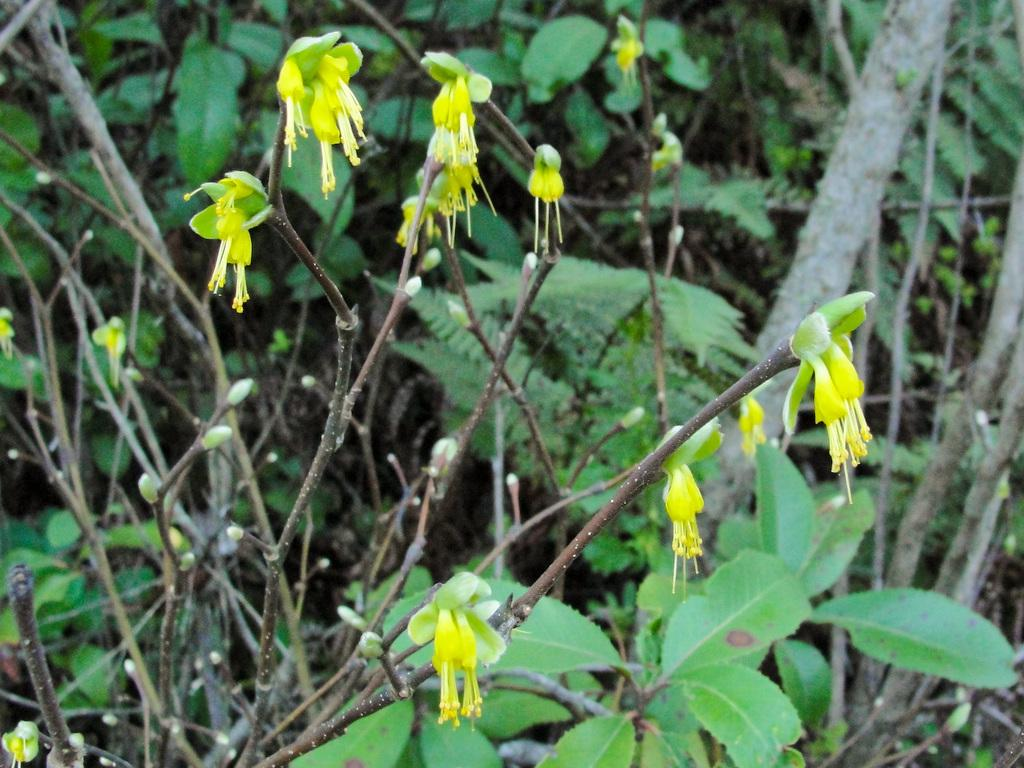What is located in the foreground of the picture? There are plants, flowers, and buds in the foreground of the picture. Can you describe the plants and flowers in the foreground? The plants and flowers in the foreground include various types of vegetation and blooms. What is visible in the background of the picture? The background of the picture is blurred, but there are trees visible. How many types of vegetation can be seen in the foreground? There are at least three types of vegetation visible in the foreground: plants, flowers, and buds. Where is the lunchroom located in the image? There is no lunchroom present in the image; it features plants, flowers, and buds in the foreground and trees in the background. What type of crown can be seen on the tree in the image? There is no crown visible on any tree in the image; it only shows the trees in the background. 